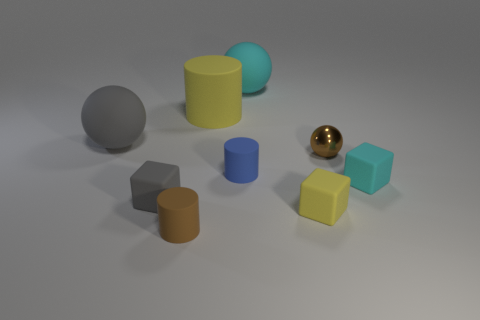What color is the thing that is on the right side of the big yellow rubber cylinder and behind the gray sphere?
Your answer should be very brief. Cyan. Is the size of the brown thing that is to the left of the blue matte thing the same as the tiny blue rubber thing?
Keep it short and to the point. Yes. Is there a small brown metal ball behind the big ball right of the yellow rubber cylinder?
Keep it short and to the point. No. What is the material of the yellow cylinder?
Provide a succinct answer. Rubber. There is a big cyan rubber sphere; are there any rubber balls left of it?
Your answer should be compact. Yes. There is a brown object that is the same shape as the tiny blue thing; what is its size?
Your answer should be compact. Small. Are there the same number of cyan balls to the right of the brown metallic sphere and small gray objects that are to the right of the blue rubber object?
Provide a succinct answer. Yes. How many big gray matte blocks are there?
Your answer should be compact. 0. Is the number of large yellow things that are to the left of the yellow rubber cylinder greater than the number of cyan rubber cubes?
Give a very brief answer. No. There is a cyan object in front of the large cylinder; what is its material?
Provide a succinct answer. Rubber. 